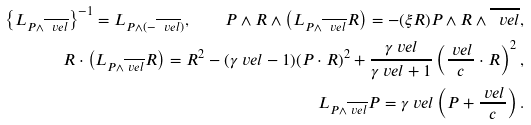Convert formula to latex. <formula><loc_0><loc_0><loc_500><loc_500>\left \{ L _ { P \wedge \overline { \ v e l } } \right \} ^ { - 1 } = L _ { P \wedge ( - \overline { \ v e l } ) } , \quad P \wedge R \wedge \left ( L _ { P \wedge \overline { \ v e l } } R \right ) = - ( \xi R ) P \wedge R \wedge \overline { \ v e l } , \\ R \cdot \left ( L _ { P \wedge \overline { \ v e l } } R \right ) = R ^ { 2 } - ( \gamma _ { \ } v e l - 1 ) ( P \cdot R ) ^ { 2 } + \frac { \gamma _ { \ } v e l } { \gamma _ { \ } v e l + 1 } \left ( \frac { \ v e l } { c } \cdot R \right ) ^ { 2 } , \\ L _ { P \wedge \overline { \ v e l } } P = \gamma _ { \ } v e l \left ( P + \frac { \ v e l } { c } \right ) .</formula> 